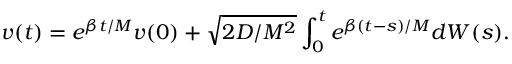<formula> <loc_0><loc_0><loc_500><loc_500>v ( t ) = e ^ { \beta t / M } v ( 0 ) + \sqrt { 2 D / M ^ { 2 } } \int _ { 0 } ^ { t } e ^ { \beta ( t - s ) / M } d W ( s ) .</formula> 